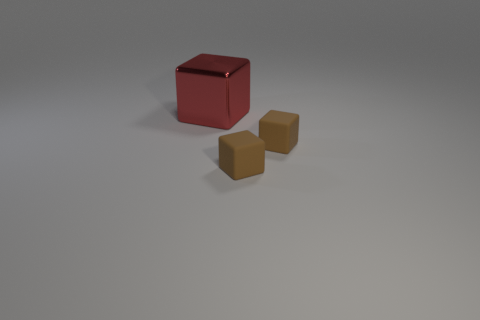Is there another big metal thing of the same color as the big metallic object?
Ensure brevity in your answer.  No. How many other objects are there of the same size as the red object?
Your response must be concise. 0. What number of other red metallic things are the same shape as the large metal object?
Provide a short and direct response. 0. How many large red blocks are left of the big shiny block?
Your answer should be very brief. 0. How many things are there?
Your answer should be very brief. 3. What is the size of the red object?
Your answer should be very brief. Large. How many other things are the same material as the big block?
Offer a very short reply. 0. Is the number of big objects greater than the number of purple things?
Keep it short and to the point. Yes. What number of objects are objects to the right of the big thing or red shiny things?
Keep it short and to the point. 3. Are there any brown rubber spheres of the same size as the red metal object?
Offer a terse response. No. 